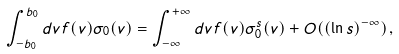<formula> <loc_0><loc_0><loc_500><loc_500>\int _ { - b _ { 0 } } ^ { b _ { 0 } } d v f ( v ) \sigma _ { 0 } ( v ) = \int _ { - \infty } ^ { + \infty } d v f ( v ) \sigma _ { 0 } ^ { s } ( v ) + O ( ( { \ln s } ) ^ { - \infty } ) \, ,</formula> 